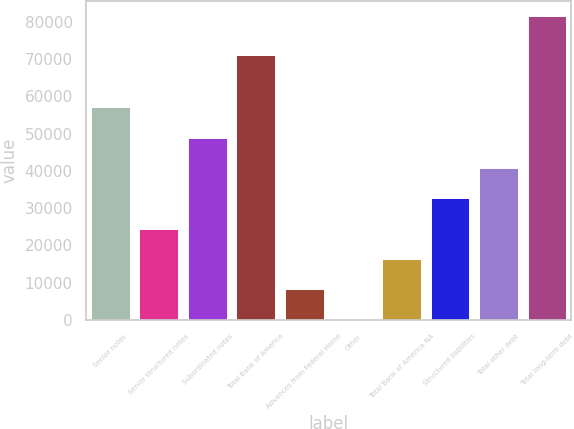Convert chart to OTSL. <chart><loc_0><loc_0><loc_500><loc_500><bar_chart><fcel>Senior notes<fcel>Senior structured notes<fcel>Subordinated notes<fcel>Total Bank of America<fcel>Advances from Federal Home<fcel>Other<fcel>Total Bank of America NA<fcel>Structured liabilities<fcel>Total other debt<fcel>Total long-term debt<nl><fcel>57086.4<fcel>24481.6<fcel>48935.2<fcel>71182<fcel>8179.2<fcel>28<fcel>16330.4<fcel>32632.8<fcel>40784<fcel>81540<nl></chart> 